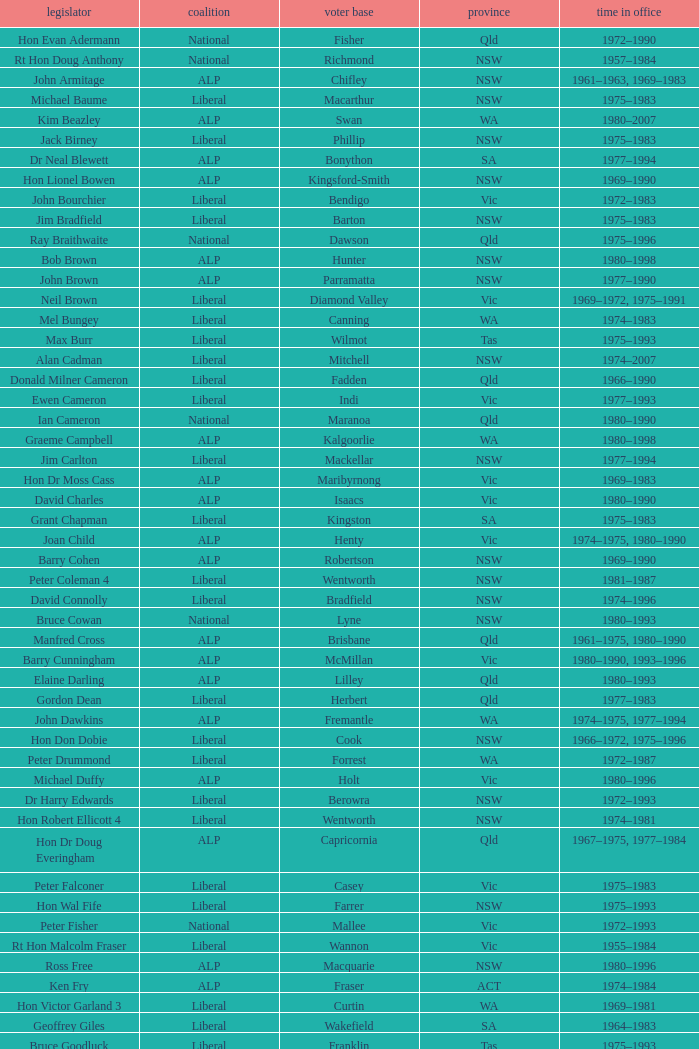Which party had a member from the state of Vic and an Electorate called Wannon? Liberal. 